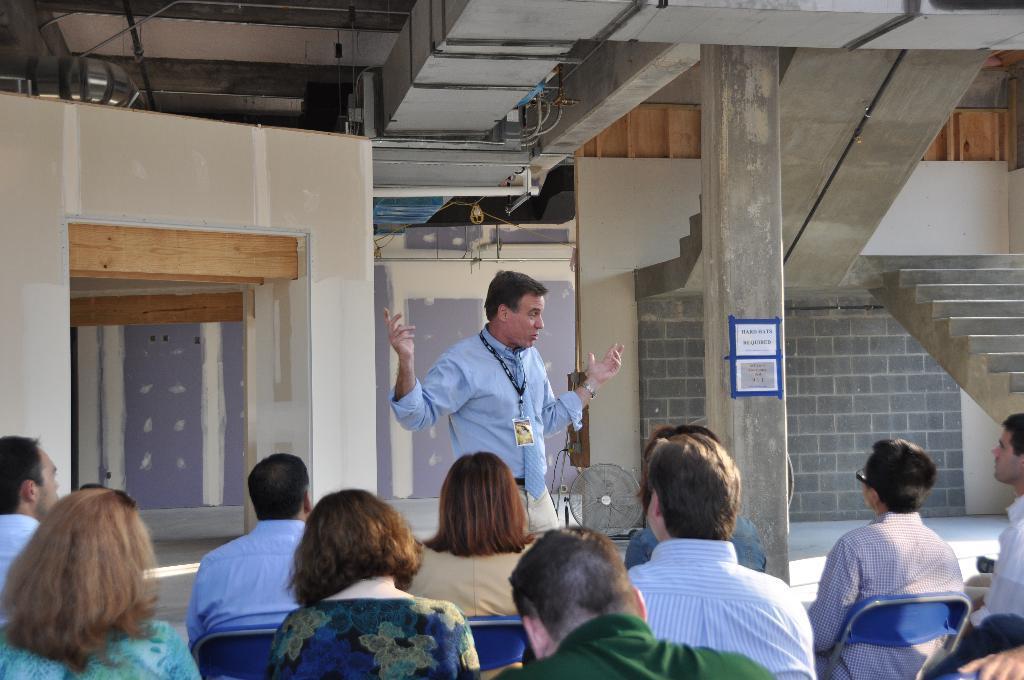Describe this image in one or two sentences. In this image at the bottom we can see few persons are sitting on the chairs and a man is standing in front of them. In the background we can see wall, light, pipes, staircase, papers attached on the pillar and an object. 